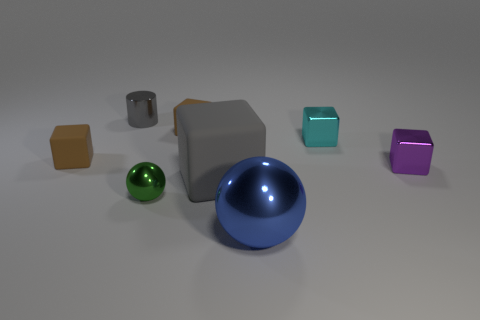Are there an equal number of big shiny objects behind the green metallic sphere and big cyan rubber cubes?
Offer a terse response. Yes. Is there a brown rubber block that has the same size as the metallic cylinder?
Your answer should be compact. Yes. Is the size of the gray cylinder the same as the brown rubber object on the right side of the tiny shiny cylinder?
Offer a terse response. Yes. Are there the same number of objects that are on the left side of the cyan shiny thing and blue balls that are behind the tiny gray metallic thing?
Provide a succinct answer. No. There is a tiny object that is the same color as the big cube; what shape is it?
Make the answer very short. Cylinder. There is a ball to the left of the big shiny object; what is its material?
Your response must be concise. Metal. Is the size of the gray matte thing the same as the green ball?
Provide a succinct answer. No. Is the number of big blue metal balls behind the tiny purple block greater than the number of yellow rubber blocks?
Provide a succinct answer. No. There is a purple block that is made of the same material as the small gray object; what is its size?
Provide a short and direct response. Small. Are there any gray blocks right of the purple object?
Keep it short and to the point. No. 